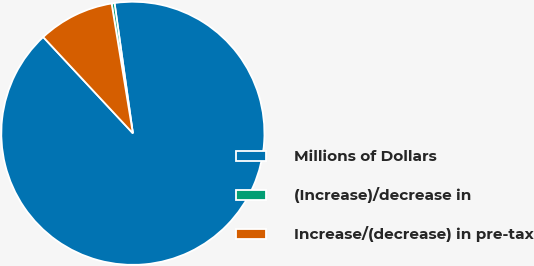<chart> <loc_0><loc_0><loc_500><loc_500><pie_chart><fcel>Millions of Dollars<fcel>(Increase)/decrease in<fcel>Increase/(decrease) in pre-tax<nl><fcel>90.29%<fcel>0.36%<fcel>9.35%<nl></chart> 